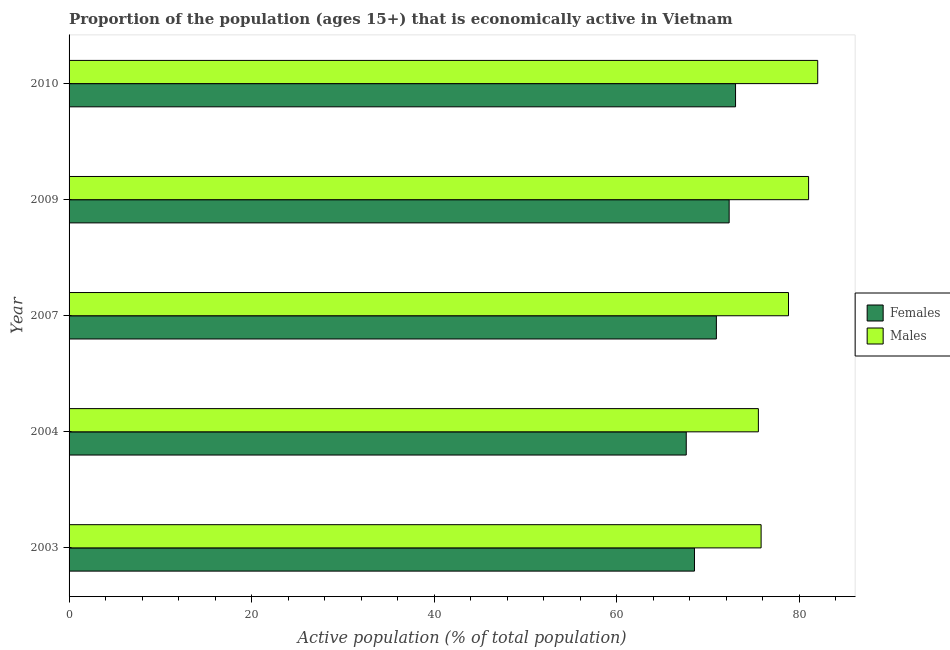How many groups of bars are there?
Keep it short and to the point. 5. How many bars are there on the 2nd tick from the bottom?
Give a very brief answer. 2. What is the percentage of economically active male population in 2004?
Offer a terse response. 75.5. Across all years, what is the maximum percentage of economically active female population?
Make the answer very short. 73. Across all years, what is the minimum percentage of economically active male population?
Your response must be concise. 75.5. In which year was the percentage of economically active male population maximum?
Ensure brevity in your answer.  2010. In which year was the percentage of economically active male population minimum?
Offer a terse response. 2004. What is the total percentage of economically active female population in the graph?
Give a very brief answer. 352.3. What is the difference between the percentage of economically active female population in 2003 and that in 2007?
Your answer should be very brief. -2.4. What is the average percentage of economically active male population per year?
Your answer should be very brief. 78.62. In the year 2010, what is the difference between the percentage of economically active female population and percentage of economically active male population?
Provide a short and direct response. -9. What is the ratio of the percentage of economically active male population in 2003 to that in 2009?
Your response must be concise. 0.94. Is the percentage of economically active female population in 2003 less than that in 2009?
Provide a succinct answer. Yes. Is the difference between the percentage of economically active male population in 2004 and 2009 greater than the difference between the percentage of economically active female population in 2004 and 2009?
Provide a short and direct response. No. What is the difference between the highest and the second highest percentage of economically active female population?
Offer a very short reply. 0.7. What is the difference between the highest and the lowest percentage of economically active female population?
Your answer should be compact. 5.4. What does the 1st bar from the top in 2007 represents?
Provide a short and direct response. Males. What does the 2nd bar from the bottom in 2004 represents?
Provide a succinct answer. Males. How many bars are there?
Give a very brief answer. 10. Are the values on the major ticks of X-axis written in scientific E-notation?
Provide a succinct answer. No. How are the legend labels stacked?
Your response must be concise. Vertical. What is the title of the graph?
Your answer should be very brief. Proportion of the population (ages 15+) that is economically active in Vietnam. Does "Overweight" appear as one of the legend labels in the graph?
Your response must be concise. No. What is the label or title of the X-axis?
Provide a succinct answer. Active population (% of total population). What is the Active population (% of total population) in Females in 2003?
Offer a very short reply. 68.5. What is the Active population (% of total population) of Males in 2003?
Give a very brief answer. 75.8. What is the Active population (% of total population) in Females in 2004?
Make the answer very short. 67.6. What is the Active population (% of total population) in Males in 2004?
Your answer should be compact. 75.5. What is the Active population (% of total population) of Females in 2007?
Your response must be concise. 70.9. What is the Active population (% of total population) of Males in 2007?
Give a very brief answer. 78.8. What is the Active population (% of total population) in Females in 2009?
Keep it short and to the point. 72.3. What is the Active population (% of total population) in Males in 2009?
Ensure brevity in your answer.  81. What is the Active population (% of total population) of Males in 2010?
Provide a succinct answer. 82. Across all years, what is the minimum Active population (% of total population) of Females?
Give a very brief answer. 67.6. Across all years, what is the minimum Active population (% of total population) in Males?
Provide a short and direct response. 75.5. What is the total Active population (% of total population) in Females in the graph?
Your answer should be compact. 352.3. What is the total Active population (% of total population) in Males in the graph?
Your response must be concise. 393.1. What is the difference between the Active population (% of total population) of Females in 2003 and that in 2004?
Keep it short and to the point. 0.9. What is the difference between the Active population (% of total population) of Males in 2003 and that in 2004?
Make the answer very short. 0.3. What is the difference between the Active population (% of total population) of Males in 2003 and that in 2009?
Ensure brevity in your answer.  -5.2. What is the difference between the Active population (% of total population) of Females in 2004 and that in 2007?
Offer a terse response. -3.3. What is the difference between the Active population (% of total population) of Males in 2004 and that in 2007?
Offer a terse response. -3.3. What is the difference between the Active population (% of total population) in Females in 2004 and that in 2009?
Offer a very short reply. -4.7. What is the difference between the Active population (% of total population) in Males in 2004 and that in 2009?
Your answer should be compact. -5.5. What is the difference between the Active population (% of total population) in Females in 2007 and that in 2009?
Your response must be concise. -1.4. What is the difference between the Active population (% of total population) of Males in 2007 and that in 2009?
Keep it short and to the point. -2.2. What is the difference between the Active population (% of total population) in Females in 2007 and that in 2010?
Provide a succinct answer. -2.1. What is the difference between the Active population (% of total population) of Males in 2007 and that in 2010?
Provide a short and direct response. -3.2. What is the difference between the Active population (% of total population) of Females in 2003 and the Active population (% of total population) of Males in 2004?
Ensure brevity in your answer.  -7. What is the difference between the Active population (% of total population) of Females in 2003 and the Active population (% of total population) of Males in 2007?
Give a very brief answer. -10.3. What is the difference between the Active population (% of total population) in Females in 2003 and the Active population (% of total population) in Males in 2009?
Provide a succinct answer. -12.5. What is the difference between the Active population (% of total population) in Females in 2003 and the Active population (% of total population) in Males in 2010?
Give a very brief answer. -13.5. What is the difference between the Active population (% of total population) in Females in 2004 and the Active population (% of total population) in Males in 2007?
Offer a terse response. -11.2. What is the difference between the Active population (% of total population) of Females in 2004 and the Active population (% of total population) of Males in 2009?
Make the answer very short. -13.4. What is the difference between the Active population (% of total population) of Females in 2004 and the Active population (% of total population) of Males in 2010?
Ensure brevity in your answer.  -14.4. What is the difference between the Active population (% of total population) of Females in 2009 and the Active population (% of total population) of Males in 2010?
Provide a short and direct response. -9.7. What is the average Active population (% of total population) of Females per year?
Provide a succinct answer. 70.46. What is the average Active population (% of total population) of Males per year?
Ensure brevity in your answer.  78.62. In the year 2003, what is the difference between the Active population (% of total population) in Females and Active population (% of total population) in Males?
Offer a terse response. -7.3. In the year 2004, what is the difference between the Active population (% of total population) in Females and Active population (% of total population) in Males?
Offer a terse response. -7.9. In the year 2009, what is the difference between the Active population (% of total population) of Females and Active population (% of total population) of Males?
Provide a short and direct response. -8.7. In the year 2010, what is the difference between the Active population (% of total population) in Females and Active population (% of total population) in Males?
Provide a succinct answer. -9. What is the ratio of the Active population (% of total population) in Females in 2003 to that in 2004?
Provide a succinct answer. 1.01. What is the ratio of the Active population (% of total population) of Males in 2003 to that in 2004?
Provide a short and direct response. 1. What is the ratio of the Active population (% of total population) in Females in 2003 to that in 2007?
Your answer should be compact. 0.97. What is the ratio of the Active population (% of total population) in Males in 2003 to that in 2007?
Make the answer very short. 0.96. What is the ratio of the Active population (% of total population) in Females in 2003 to that in 2009?
Offer a very short reply. 0.95. What is the ratio of the Active population (% of total population) in Males in 2003 to that in 2009?
Make the answer very short. 0.94. What is the ratio of the Active population (% of total population) of Females in 2003 to that in 2010?
Your answer should be very brief. 0.94. What is the ratio of the Active population (% of total population) of Males in 2003 to that in 2010?
Ensure brevity in your answer.  0.92. What is the ratio of the Active population (% of total population) in Females in 2004 to that in 2007?
Offer a very short reply. 0.95. What is the ratio of the Active population (% of total population) of Males in 2004 to that in 2007?
Your answer should be compact. 0.96. What is the ratio of the Active population (% of total population) in Females in 2004 to that in 2009?
Keep it short and to the point. 0.94. What is the ratio of the Active population (% of total population) in Males in 2004 to that in 2009?
Give a very brief answer. 0.93. What is the ratio of the Active population (% of total population) in Females in 2004 to that in 2010?
Your answer should be very brief. 0.93. What is the ratio of the Active population (% of total population) in Males in 2004 to that in 2010?
Give a very brief answer. 0.92. What is the ratio of the Active population (% of total population) of Females in 2007 to that in 2009?
Your answer should be compact. 0.98. What is the ratio of the Active population (% of total population) in Males in 2007 to that in 2009?
Keep it short and to the point. 0.97. What is the ratio of the Active population (% of total population) of Females in 2007 to that in 2010?
Your answer should be compact. 0.97. What is the difference between the highest and the second highest Active population (% of total population) of Females?
Your answer should be very brief. 0.7. What is the difference between the highest and the lowest Active population (% of total population) in Males?
Ensure brevity in your answer.  6.5. 